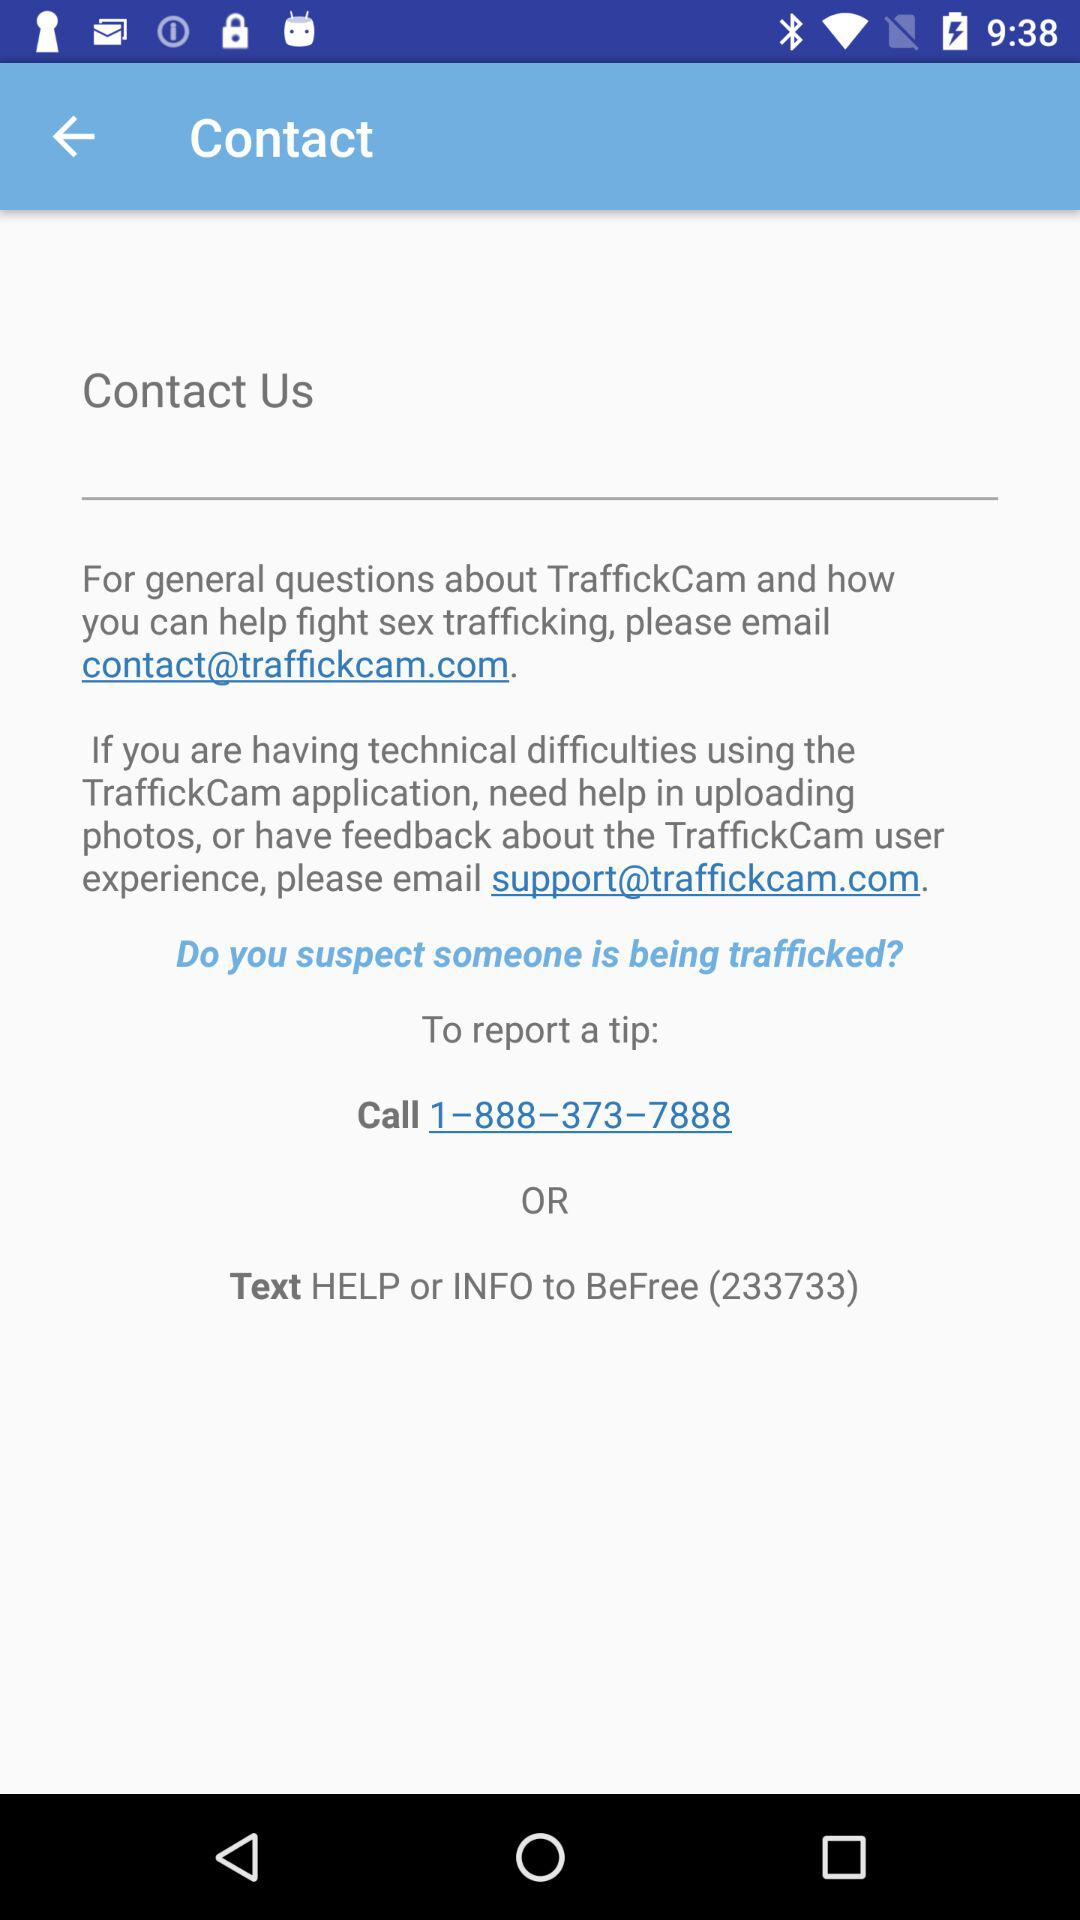What is the text number to send text? The number is 233733. 